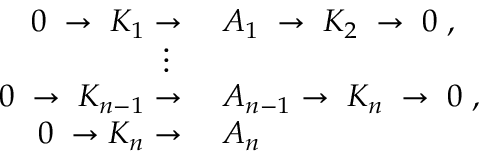Convert formula to latex. <formula><loc_0><loc_0><loc_500><loc_500>\begin{array} { r l } { 0 \, \rightarrow \, K _ { 1 } } & A _ { 1 } \, \rightarrow \, K _ { 2 } \, \rightarrow \, 0 \, , } \\ { \vdots \, } \\ { 0 \, \rightarrow \, K _ { n - 1 } } & A _ { n - 1 } \rightarrow \, K _ { n } \, \rightarrow \, 0 \, , } \\ { 0 \, \rightarrow K _ { n } } & A _ { n } } \end{array}</formula> 